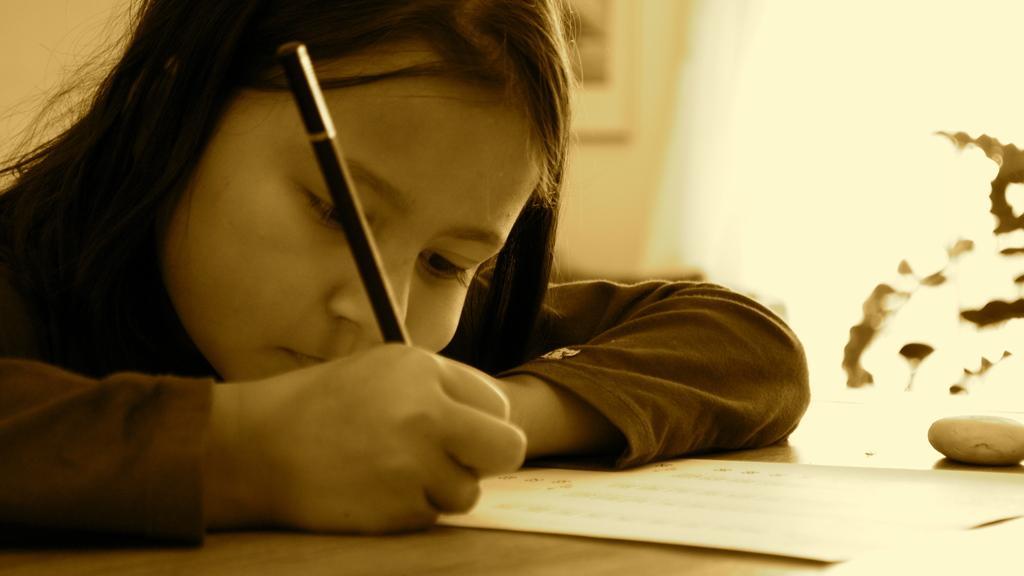In one or two sentences, can you explain what this image depicts? In this image i can see a girl holding a pencil and writing something on the paper which is on the table. In the background i can see the wall, the photo frame and a plant. 